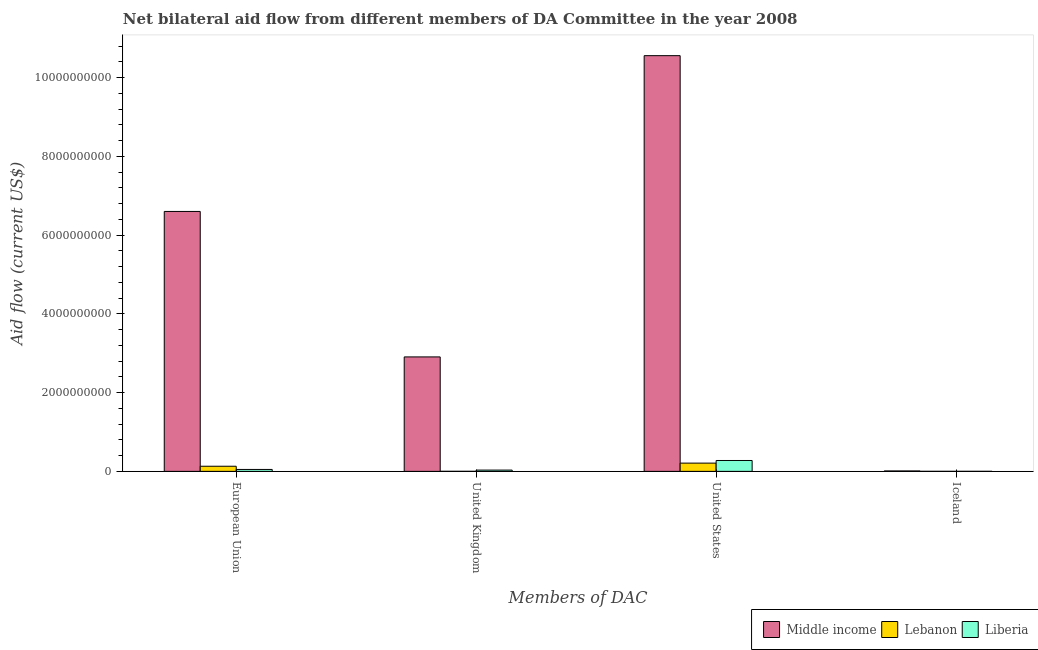Are the number of bars per tick equal to the number of legend labels?
Your response must be concise. Yes. Are the number of bars on each tick of the X-axis equal?
Your response must be concise. Yes. How many bars are there on the 2nd tick from the left?
Offer a very short reply. 3. What is the amount of aid given by uk in Liberia?
Your answer should be very brief. 3.24e+07. Across all countries, what is the maximum amount of aid given by uk?
Make the answer very short. 2.91e+09. Across all countries, what is the minimum amount of aid given by uk?
Offer a very short reply. 1.04e+06. In which country was the amount of aid given by us minimum?
Keep it short and to the point. Lebanon. What is the total amount of aid given by eu in the graph?
Offer a very short reply. 6.78e+09. What is the difference between the amount of aid given by uk in Liberia and that in Middle income?
Provide a short and direct response. -2.87e+09. What is the difference between the amount of aid given by uk in Lebanon and the amount of aid given by iceland in Middle income?
Your answer should be very brief. -9.59e+06. What is the average amount of aid given by us per country?
Make the answer very short. 3.68e+09. What is the difference between the amount of aid given by eu and amount of aid given by uk in Liberia?
Your answer should be compact. 1.62e+07. In how many countries, is the amount of aid given by eu greater than 400000000 US$?
Your answer should be very brief. 1. What is the ratio of the amount of aid given by uk in Lebanon to that in Liberia?
Provide a succinct answer. 0.03. Is the amount of aid given by uk in Lebanon less than that in Liberia?
Your response must be concise. Yes. Is the difference between the amount of aid given by uk in Middle income and Lebanon greater than the difference between the amount of aid given by us in Middle income and Lebanon?
Provide a short and direct response. No. What is the difference between the highest and the second highest amount of aid given by iceland?
Offer a terse response. 1.01e+07. What is the difference between the highest and the lowest amount of aid given by eu?
Offer a terse response. 6.55e+09. In how many countries, is the amount of aid given by us greater than the average amount of aid given by us taken over all countries?
Your answer should be very brief. 1. Is it the case that in every country, the sum of the amount of aid given by eu and amount of aid given by us is greater than the sum of amount of aid given by uk and amount of aid given by iceland?
Provide a short and direct response. No. What does the 1st bar from the left in Iceland represents?
Your response must be concise. Middle income. What does the 3rd bar from the right in United States represents?
Give a very brief answer. Middle income. How many bars are there?
Provide a short and direct response. 12. Are all the bars in the graph horizontal?
Offer a terse response. No. How many legend labels are there?
Provide a short and direct response. 3. What is the title of the graph?
Your answer should be compact. Net bilateral aid flow from different members of DA Committee in the year 2008. Does "El Salvador" appear as one of the legend labels in the graph?
Offer a very short reply. No. What is the label or title of the X-axis?
Keep it short and to the point. Members of DAC. What is the label or title of the Y-axis?
Keep it short and to the point. Aid flow (current US$). What is the Aid flow (current US$) in Middle income in European Union?
Your response must be concise. 6.60e+09. What is the Aid flow (current US$) of Lebanon in European Union?
Provide a succinct answer. 1.30e+08. What is the Aid flow (current US$) of Liberia in European Union?
Your response must be concise. 4.86e+07. What is the Aid flow (current US$) of Middle income in United Kingdom?
Your response must be concise. 2.91e+09. What is the Aid flow (current US$) in Lebanon in United Kingdom?
Your response must be concise. 1.04e+06. What is the Aid flow (current US$) of Liberia in United Kingdom?
Offer a very short reply. 3.24e+07. What is the Aid flow (current US$) in Middle income in United States?
Your answer should be very brief. 1.06e+1. What is the Aid flow (current US$) of Lebanon in United States?
Your answer should be very brief. 2.10e+08. What is the Aid flow (current US$) of Liberia in United States?
Give a very brief answer. 2.76e+08. What is the Aid flow (current US$) of Middle income in Iceland?
Provide a short and direct response. 1.06e+07. What is the Aid flow (current US$) of Liberia in Iceland?
Offer a very short reply. 5.30e+05. Across all Members of DAC, what is the maximum Aid flow (current US$) in Middle income?
Your answer should be very brief. 1.06e+1. Across all Members of DAC, what is the maximum Aid flow (current US$) of Lebanon?
Your answer should be very brief. 2.10e+08. Across all Members of DAC, what is the maximum Aid flow (current US$) in Liberia?
Keep it short and to the point. 2.76e+08. Across all Members of DAC, what is the minimum Aid flow (current US$) of Middle income?
Offer a terse response. 1.06e+07. Across all Members of DAC, what is the minimum Aid flow (current US$) of Liberia?
Offer a very short reply. 5.30e+05. What is the total Aid flow (current US$) of Middle income in the graph?
Your response must be concise. 2.01e+1. What is the total Aid flow (current US$) in Lebanon in the graph?
Offer a very short reply. 3.41e+08. What is the total Aid flow (current US$) in Liberia in the graph?
Provide a short and direct response. 3.58e+08. What is the difference between the Aid flow (current US$) of Middle income in European Union and that in United Kingdom?
Your answer should be compact. 3.69e+09. What is the difference between the Aid flow (current US$) of Lebanon in European Union and that in United Kingdom?
Your answer should be compact. 1.29e+08. What is the difference between the Aid flow (current US$) of Liberia in European Union and that in United Kingdom?
Ensure brevity in your answer.  1.62e+07. What is the difference between the Aid flow (current US$) of Middle income in European Union and that in United States?
Make the answer very short. -3.96e+09. What is the difference between the Aid flow (current US$) of Lebanon in European Union and that in United States?
Your answer should be compact. -7.93e+07. What is the difference between the Aid flow (current US$) in Liberia in European Union and that in United States?
Your answer should be very brief. -2.27e+08. What is the difference between the Aid flow (current US$) in Middle income in European Union and that in Iceland?
Keep it short and to the point. 6.59e+09. What is the difference between the Aid flow (current US$) of Lebanon in European Union and that in Iceland?
Your answer should be very brief. 1.30e+08. What is the difference between the Aid flow (current US$) in Liberia in European Union and that in Iceland?
Give a very brief answer. 4.81e+07. What is the difference between the Aid flow (current US$) of Middle income in United Kingdom and that in United States?
Your response must be concise. -7.65e+09. What is the difference between the Aid flow (current US$) in Lebanon in United Kingdom and that in United States?
Offer a terse response. -2.09e+08. What is the difference between the Aid flow (current US$) of Liberia in United Kingdom and that in United States?
Your answer should be compact. -2.44e+08. What is the difference between the Aid flow (current US$) of Middle income in United Kingdom and that in Iceland?
Your answer should be compact. 2.90e+09. What is the difference between the Aid flow (current US$) in Liberia in United Kingdom and that in Iceland?
Your answer should be compact. 3.19e+07. What is the difference between the Aid flow (current US$) in Middle income in United States and that in Iceland?
Your answer should be very brief. 1.05e+1. What is the difference between the Aid flow (current US$) in Lebanon in United States and that in Iceland?
Make the answer very short. 2.09e+08. What is the difference between the Aid flow (current US$) in Liberia in United States and that in Iceland?
Your response must be concise. 2.75e+08. What is the difference between the Aid flow (current US$) in Middle income in European Union and the Aid flow (current US$) in Lebanon in United Kingdom?
Offer a very short reply. 6.60e+09. What is the difference between the Aid flow (current US$) in Middle income in European Union and the Aid flow (current US$) in Liberia in United Kingdom?
Your response must be concise. 6.57e+09. What is the difference between the Aid flow (current US$) of Lebanon in European Union and the Aid flow (current US$) of Liberia in United Kingdom?
Offer a very short reply. 9.78e+07. What is the difference between the Aid flow (current US$) in Middle income in European Union and the Aid flow (current US$) in Lebanon in United States?
Ensure brevity in your answer.  6.39e+09. What is the difference between the Aid flow (current US$) of Middle income in European Union and the Aid flow (current US$) of Liberia in United States?
Your answer should be compact. 6.33e+09. What is the difference between the Aid flow (current US$) in Lebanon in European Union and the Aid flow (current US$) in Liberia in United States?
Your answer should be compact. -1.46e+08. What is the difference between the Aid flow (current US$) in Middle income in European Union and the Aid flow (current US$) in Lebanon in Iceland?
Provide a succinct answer. 6.60e+09. What is the difference between the Aid flow (current US$) in Middle income in European Union and the Aid flow (current US$) in Liberia in Iceland?
Your answer should be compact. 6.60e+09. What is the difference between the Aid flow (current US$) of Lebanon in European Union and the Aid flow (current US$) of Liberia in Iceland?
Ensure brevity in your answer.  1.30e+08. What is the difference between the Aid flow (current US$) of Middle income in United Kingdom and the Aid flow (current US$) of Lebanon in United States?
Provide a succinct answer. 2.70e+09. What is the difference between the Aid flow (current US$) in Middle income in United Kingdom and the Aid flow (current US$) in Liberia in United States?
Your response must be concise. 2.63e+09. What is the difference between the Aid flow (current US$) of Lebanon in United Kingdom and the Aid flow (current US$) of Liberia in United States?
Keep it short and to the point. -2.75e+08. What is the difference between the Aid flow (current US$) of Middle income in United Kingdom and the Aid flow (current US$) of Lebanon in Iceland?
Offer a terse response. 2.91e+09. What is the difference between the Aid flow (current US$) of Middle income in United Kingdom and the Aid flow (current US$) of Liberia in Iceland?
Your response must be concise. 2.91e+09. What is the difference between the Aid flow (current US$) of Lebanon in United Kingdom and the Aid flow (current US$) of Liberia in Iceland?
Provide a succinct answer. 5.10e+05. What is the difference between the Aid flow (current US$) of Middle income in United States and the Aid flow (current US$) of Lebanon in Iceland?
Keep it short and to the point. 1.06e+1. What is the difference between the Aid flow (current US$) in Middle income in United States and the Aid flow (current US$) in Liberia in Iceland?
Ensure brevity in your answer.  1.06e+1. What is the difference between the Aid flow (current US$) of Lebanon in United States and the Aid flow (current US$) of Liberia in Iceland?
Your answer should be very brief. 2.09e+08. What is the average Aid flow (current US$) of Middle income per Members of DAC?
Your response must be concise. 5.02e+09. What is the average Aid flow (current US$) of Lebanon per Members of DAC?
Make the answer very short. 8.54e+07. What is the average Aid flow (current US$) of Liberia per Members of DAC?
Keep it short and to the point. 8.94e+07. What is the difference between the Aid flow (current US$) of Middle income and Aid flow (current US$) of Lebanon in European Union?
Give a very brief answer. 6.47e+09. What is the difference between the Aid flow (current US$) in Middle income and Aid flow (current US$) in Liberia in European Union?
Provide a succinct answer. 6.55e+09. What is the difference between the Aid flow (current US$) of Lebanon and Aid flow (current US$) of Liberia in European Union?
Ensure brevity in your answer.  8.17e+07. What is the difference between the Aid flow (current US$) in Middle income and Aid flow (current US$) in Lebanon in United Kingdom?
Provide a short and direct response. 2.91e+09. What is the difference between the Aid flow (current US$) in Middle income and Aid flow (current US$) in Liberia in United Kingdom?
Give a very brief answer. 2.87e+09. What is the difference between the Aid flow (current US$) in Lebanon and Aid flow (current US$) in Liberia in United Kingdom?
Provide a short and direct response. -3.14e+07. What is the difference between the Aid flow (current US$) in Middle income and Aid flow (current US$) in Lebanon in United States?
Ensure brevity in your answer.  1.03e+1. What is the difference between the Aid flow (current US$) of Middle income and Aid flow (current US$) of Liberia in United States?
Your answer should be compact. 1.03e+1. What is the difference between the Aid flow (current US$) of Lebanon and Aid flow (current US$) of Liberia in United States?
Provide a short and direct response. -6.64e+07. What is the difference between the Aid flow (current US$) in Middle income and Aid flow (current US$) in Lebanon in Iceland?
Offer a very short reply. 1.01e+07. What is the difference between the Aid flow (current US$) of Middle income and Aid flow (current US$) of Liberia in Iceland?
Give a very brief answer. 1.01e+07. What is the ratio of the Aid flow (current US$) of Middle income in European Union to that in United Kingdom?
Your answer should be very brief. 2.27. What is the ratio of the Aid flow (current US$) of Lebanon in European Union to that in United Kingdom?
Provide a succinct answer. 125.24. What is the ratio of the Aid flow (current US$) in Liberia in European Union to that in United Kingdom?
Keep it short and to the point. 1.5. What is the ratio of the Aid flow (current US$) of Middle income in European Union to that in United States?
Your response must be concise. 0.63. What is the ratio of the Aid flow (current US$) of Lebanon in European Union to that in United States?
Keep it short and to the point. 0.62. What is the ratio of the Aid flow (current US$) in Liberia in European Union to that in United States?
Offer a terse response. 0.18. What is the ratio of the Aid flow (current US$) of Middle income in European Union to that in Iceland?
Make the answer very short. 620.99. What is the ratio of the Aid flow (current US$) of Lebanon in European Union to that in Iceland?
Make the answer very short. 236.82. What is the ratio of the Aid flow (current US$) of Liberia in European Union to that in Iceland?
Your answer should be compact. 91.68. What is the ratio of the Aid flow (current US$) of Middle income in United Kingdom to that in United States?
Provide a short and direct response. 0.28. What is the ratio of the Aid flow (current US$) of Lebanon in United Kingdom to that in United States?
Provide a short and direct response. 0.01. What is the ratio of the Aid flow (current US$) in Liberia in United Kingdom to that in United States?
Give a very brief answer. 0.12. What is the ratio of the Aid flow (current US$) in Middle income in United Kingdom to that in Iceland?
Make the answer very short. 273.45. What is the ratio of the Aid flow (current US$) of Lebanon in United Kingdom to that in Iceland?
Your answer should be very brief. 1.89. What is the ratio of the Aid flow (current US$) in Liberia in United Kingdom to that in Iceland?
Offer a terse response. 61.13. What is the ratio of the Aid flow (current US$) of Middle income in United States to that in Iceland?
Provide a short and direct response. 993.2. What is the ratio of the Aid flow (current US$) in Lebanon in United States to that in Iceland?
Your answer should be compact. 381.05. What is the ratio of the Aid flow (current US$) in Liberia in United States to that in Iceland?
Provide a short and direct response. 520.74. What is the difference between the highest and the second highest Aid flow (current US$) of Middle income?
Your answer should be very brief. 3.96e+09. What is the difference between the highest and the second highest Aid flow (current US$) of Lebanon?
Ensure brevity in your answer.  7.93e+07. What is the difference between the highest and the second highest Aid flow (current US$) of Liberia?
Make the answer very short. 2.27e+08. What is the difference between the highest and the lowest Aid flow (current US$) of Middle income?
Your response must be concise. 1.05e+1. What is the difference between the highest and the lowest Aid flow (current US$) of Lebanon?
Offer a terse response. 2.09e+08. What is the difference between the highest and the lowest Aid flow (current US$) in Liberia?
Offer a terse response. 2.75e+08. 